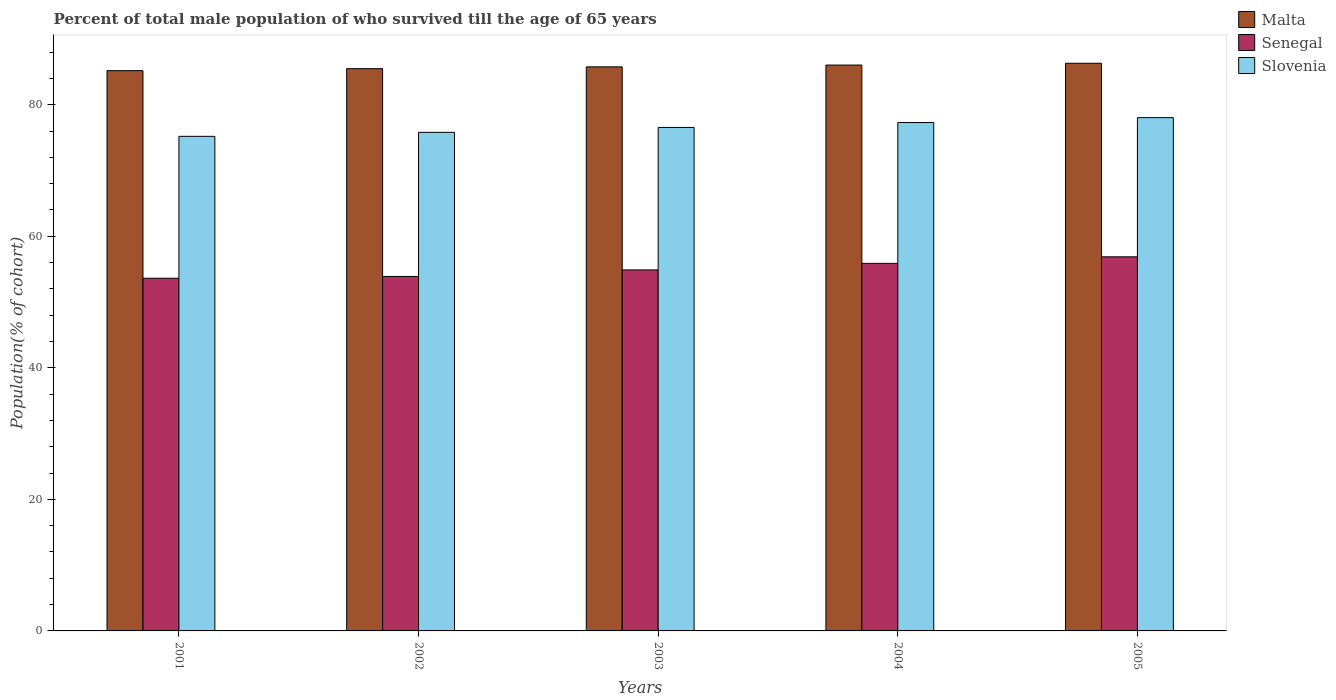How many different coloured bars are there?
Ensure brevity in your answer.  3. Are the number of bars per tick equal to the number of legend labels?
Keep it short and to the point. Yes. Are the number of bars on each tick of the X-axis equal?
Offer a terse response. Yes. How many bars are there on the 5th tick from the left?
Provide a succinct answer. 3. How many bars are there on the 5th tick from the right?
Keep it short and to the point. 3. In how many cases, is the number of bars for a given year not equal to the number of legend labels?
Your response must be concise. 0. What is the percentage of total male population who survived till the age of 65 years in Slovenia in 2005?
Your answer should be very brief. 78.04. Across all years, what is the maximum percentage of total male population who survived till the age of 65 years in Senegal?
Provide a short and direct response. 56.88. Across all years, what is the minimum percentage of total male population who survived till the age of 65 years in Malta?
Ensure brevity in your answer.  85.18. In which year was the percentage of total male population who survived till the age of 65 years in Slovenia minimum?
Your answer should be very brief. 2001. What is the total percentage of total male population who survived till the age of 65 years in Malta in the graph?
Give a very brief answer. 428.75. What is the difference between the percentage of total male population who survived till the age of 65 years in Senegal in 2004 and that in 2005?
Provide a short and direct response. -0.99. What is the difference between the percentage of total male population who survived till the age of 65 years in Senegal in 2005 and the percentage of total male population who survived till the age of 65 years in Slovenia in 2004?
Provide a succinct answer. -20.42. What is the average percentage of total male population who survived till the age of 65 years in Slovenia per year?
Your answer should be compact. 76.57. In the year 2005, what is the difference between the percentage of total male population who survived till the age of 65 years in Malta and percentage of total male population who survived till the age of 65 years in Slovenia?
Offer a very short reply. 8.27. In how many years, is the percentage of total male population who survived till the age of 65 years in Senegal greater than 8 %?
Provide a succinct answer. 5. What is the ratio of the percentage of total male population who survived till the age of 65 years in Malta in 2003 to that in 2005?
Ensure brevity in your answer.  0.99. Is the percentage of total male population who survived till the age of 65 years in Malta in 2002 less than that in 2004?
Make the answer very short. Yes. Is the difference between the percentage of total male population who survived till the age of 65 years in Malta in 2001 and 2002 greater than the difference between the percentage of total male population who survived till the age of 65 years in Slovenia in 2001 and 2002?
Provide a short and direct response. Yes. What is the difference between the highest and the second highest percentage of total male population who survived till the age of 65 years in Slovenia?
Keep it short and to the point. 0.75. What is the difference between the highest and the lowest percentage of total male population who survived till the age of 65 years in Malta?
Give a very brief answer. 1.12. In how many years, is the percentage of total male population who survived till the age of 65 years in Slovenia greater than the average percentage of total male population who survived till the age of 65 years in Slovenia taken over all years?
Ensure brevity in your answer.  2. Is the sum of the percentage of total male population who survived till the age of 65 years in Slovenia in 2001 and 2002 greater than the maximum percentage of total male population who survived till the age of 65 years in Malta across all years?
Provide a succinct answer. Yes. What does the 2nd bar from the left in 2005 represents?
Your answer should be very brief. Senegal. What does the 3rd bar from the right in 2003 represents?
Offer a very short reply. Malta. Is it the case that in every year, the sum of the percentage of total male population who survived till the age of 65 years in Malta and percentage of total male population who survived till the age of 65 years in Slovenia is greater than the percentage of total male population who survived till the age of 65 years in Senegal?
Give a very brief answer. Yes. How many bars are there?
Ensure brevity in your answer.  15. Are the values on the major ticks of Y-axis written in scientific E-notation?
Make the answer very short. No. Does the graph contain grids?
Give a very brief answer. No. How are the legend labels stacked?
Offer a terse response. Vertical. What is the title of the graph?
Your answer should be very brief. Percent of total male population of who survived till the age of 65 years. What is the label or title of the Y-axis?
Offer a terse response. Population(% of cohort). What is the Population(% of cohort) in Malta in 2001?
Your answer should be compact. 85.18. What is the Population(% of cohort) of Senegal in 2001?
Make the answer very short. 53.62. What is the Population(% of cohort) in Slovenia in 2001?
Provide a succinct answer. 75.19. What is the Population(% of cohort) of Malta in 2002?
Your response must be concise. 85.48. What is the Population(% of cohort) in Senegal in 2002?
Your response must be concise. 53.89. What is the Population(% of cohort) in Slovenia in 2002?
Provide a succinct answer. 75.8. What is the Population(% of cohort) of Malta in 2003?
Give a very brief answer. 85.76. What is the Population(% of cohort) in Senegal in 2003?
Provide a short and direct response. 54.89. What is the Population(% of cohort) of Slovenia in 2003?
Provide a succinct answer. 76.55. What is the Population(% of cohort) in Malta in 2004?
Your answer should be very brief. 86.03. What is the Population(% of cohort) of Senegal in 2004?
Your response must be concise. 55.88. What is the Population(% of cohort) of Slovenia in 2004?
Ensure brevity in your answer.  77.29. What is the Population(% of cohort) of Malta in 2005?
Ensure brevity in your answer.  86.3. What is the Population(% of cohort) in Senegal in 2005?
Keep it short and to the point. 56.88. What is the Population(% of cohort) of Slovenia in 2005?
Keep it short and to the point. 78.04. Across all years, what is the maximum Population(% of cohort) in Malta?
Keep it short and to the point. 86.3. Across all years, what is the maximum Population(% of cohort) of Senegal?
Offer a terse response. 56.88. Across all years, what is the maximum Population(% of cohort) of Slovenia?
Offer a very short reply. 78.04. Across all years, what is the minimum Population(% of cohort) of Malta?
Offer a very short reply. 85.18. Across all years, what is the minimum Population(% of cohort) of Senegal?
Provide a short and direct response. 53.62. Across all years, what is the minimum Population(% of cohort) of Slovenia?
Your answer should be compact. 75.19. What is the total Population(% of cohort) of Malta in the graph?
Ensure brevity in your answer.  428.75. What is the total Population(% of cohort) in Senegal in the graph?
Make the answer very short. 275.16. What is the total Population(% of cohort) of Slovenia in the graph?
Your answer should be compact. 382.87. What is the difference between the Population(% of cohort) of Malta in 2001 and that in 2002?
Your answer should be compact. -0.3. What is the difference between the Population(% of cohort) in Senegal in 2001 and that in 2002?
Ensure brevity in your answer.  -0.27. What is the difference between the Population(% of cohort) in Slovenia in 2001 and that in 2002?
Ensure brevity in your answer.  -0.61. What is the difference between the Population(% of cohort) of Malta in 2001 and that in 2003?
Keep it short and to the point. -0.58. What is the difference between the Population(% of cohort) of Senegal in 2001 and that in 2003?
Ensure brevity in your answer.  -1.26. What is the difference between the Population(% of cohort) of Slovenia in 2001 and that in 2003?
Make the answer very short. -1.35. What is the difference between the Population(% of cohort) of Malta in 2001 and that in 2004?
Offer a terse response. -0.85. What is the difference between the Population(% of cohort) of Senegal in 2001 and that in 2004?
Provide a succinct answer. -2.26. What is the difference between the Population(% of cohort) in Slovenia in 2001 and that in 2004?
Keep it short and to the point. -2.1. What is the difference between the Population(% of cohort) of Malta in 2001 and that in 2005?
Your answer should be very brief. -1.12. What is the difference between the Population(% of cohort) of Senegal in 2001 and that in 2005?
Give a very brief answer. -3.25. What is the difference between the Population(% of cohort) of Slovenia in 2001 and that in 2005?
Keep it short and to the point. -2.84. What is the difference between the Population(% of cohort) in Malta in 2002 and that in 2003?
Give a very brief answer. -0.27. What is the difference between the Population(% of cohort) of Senegal in 2002 and that in 2003?
Offer a very short reply. -0.99. What is the difference between the Population(% of cohort) in Slovenia in 2002 and that in 2003?
Your response must be concise. -0.74. What is the difference between the Population(% of cohort) of Malta in 2002 and that in 2004?
Make the answer very short. -0.55. What is the difference between the Population(% of cohort) of Senegal in 2002 and that in 2004?
Your answer should be very brief. -1.99. What is the difference between the Population(% of cohort) of Slovenia in 2002 and that in 2004?
Provide a succinct answer. -1.49. What is the difference between the Population(% of cohort) in Malta in 2002 and that in 2005?
Offer a very short reply. -0.82. What is the difference between the Population(% of cohort) of Senegal in 2002 and that in 2005?
Your answer should be very brief. -2.98. What is the difference between the Population(% of cohort) in Slovenia in 2002 and that in 2005?
Offer a very short reply. -2.24. What is the difference between the Population(% of cohort) of Malta in 2003 and that in 2004?
Your response must be concise. -0.27. What is the difference between the Population(% of cohort) of Senegal in 2003 and that in 2004?
Your answer should be very brief. -0.99. What is the difference between the Population(% of cohort) of Slovenia in 2003 and that in 2004?
Offer a very short reply. -0.74. What is the difference between the Population(% of cohort) in Malta in 2003 and that in 2005?
Your response must be concise. -0.55. What is the difference between the Population(% of cohort) in Senegal in 2003 and that in 2005?
Provide a succinct answer. -1.99. What is the difference between the Population(% of cohort) in Slovenia in 2003 and that in 2005?
Give a very brief answer. -1.49. What is the difference between the Population(% of cohort) of Malta in 2004 and that in 2005?
Your answer should be compact. -0.27. What is the difference between the Population(% of cohort) in Senegal in 2004 and that in 2005?
Make the answer very short. -0.99. What is the difference between the Population(% of cohort) in Slovenia in 2004 and that in 2005?
Provide a succinct answer. -0.74. What is the difference between the Population(% of cohort) in Malta in 2001 and the Population(% of cohort) in Senegal in 2002?
Your answer should be compact. 31.29. What is the difference between the Population(% of cohort) of Malta in 2001 and the Population(% of cohort) of Slovenia in 2002?
Provide a short and direct response. 9.38. What is the difference between the Population(% of cohort) in Senegal in 2001 and the Population(% of cohort) in Slovenia in 2002?
Offer a terse response. -22.18. What is the difference between the Population(% of cohort) of Malta in 2001 and the Population(% of cohort) of Senegal in 2003?
Provide a short and direct response. 30.29. What is the difference between the Population(% of cohort) in Malta in 2001 and the Population(% of cohort) in Slovenia in 2003?
Your response must be concise. 8.63. What is the difference between the Population(% of cohort) of Senegal in 2001 and the Population(% of cohort) of Slovenia in 2003?
Offer a very short reply. -22.92. What is the difference between the Population(% of cohort) of Malta in 2001 and the Population(% of cohort) of Senegal in 2004?
Give a very brief answer. 29.3. What is the difference between the Population(% of cohort) in Malta in 2001 and the Population(% of cohort) in Slovenia in 2004?
Provide a short and direct response. 7.89. What is the difference between the Population(% of cohort) in Senegal in 2001 and the Population(% of cohort) in Slovenia in 2004?
Keep it short and to the point. -23.67. What is the difference between the Population(% of cohort) in Malta in 2001 and the Population(% of cohort) in Senegal in 2005?
Your answer should be compact. 28.3. What is the difference between the Population(% of cohort) in Malta in 2001 and the Population(% of cohort) in Slovenia in 2005?
Give a very brief answer. 7.14. What is the difference between the Population(% of cohort) in Senegal in 2001 and the Population(% of cohort) in Slovenia in 2005?
Provide a succinct answer. -24.41. What is the difference between the Population(% of cohort) in Malta in 2002 and the Population(% of cohort) in Senegal in 2003?
Keep it short and to the point. 30.6. What is the difference between the Population(% of cohort) of Malta in 2002 and the Population(% of cohort) of Slovenia in 2003?
Ensure brevity in your answer.  8.94. What is the difference between the Population(% of cohort) in Senegal in 2002 and the Population(% of cohort) in Slovenia in 2003?
Offer a terse response. -22.65. What is the difference between the Population(% of cohort) in Malta in 2002 and the Population(% of cohort) in Senegal in 2004?
Keep it short and to the point. 29.6. What is the difference between the Population(% of cohort) in Malta in 2002 and the Population(% of cohort) in Slovenia in 2004?
Give a very brief answer. 8.19. What is the difference between the Population(% of cohort) of Senegal in 2002 and the Population(% of cohort) of Slovenia in 2004?
Give a very brief answer. -23.4. What is the difference between the Population(% of cohort) of Malta in 2002 and the Population(% of cohort) of Senegal in 2005?
Ensure brevity in your answer.  28.61. What is the difference between the Population(% of cohort) of Malta in 2002 and the Population(% of cohort) of Slovenia in 2005?
Give a very brief answer. 7.45. What is the difference between the Population(% of cohort) in Senegal in 2002 and the Population(% of cohort) in Slovenia in 2005?
Give a very brief answer. -24.14. What is the difference between the Population(% of cohort) of Malta in 2003 and the Population(% of cohort) of Senegal in 2004?
Offer a very short reply. 29.88. What is the difference between the Population(% of cohort) of Malta in 2003 and the Population(% of cohort) of Slovenia in 2004?
Ensure brevity in your answer.  8.46. What is the difference between the Population(% of cohort) of Senegal in 2003 and the Population(% of cohort) of Slovenia in 2004?
Your response must be concise. -22.4. What is the difference between the Population(% of cohort) in Malta in 2003 and the Population(% of cohort) in Senegal in 2005?
Offer a terse response. 28.88. What is the difference between the Population(% of cohort) in Malta in 2003 and the Population(% of cohort) in Slovenia in 2005?
Keep it short and to the point. 7.72. What is the difference between the Population(% of cohort) in Senegal in 2003 and the Population(% of cohort) in Slovenia in 2005?
Give a very brief answer. -23.15. What is the difference between the Population(% of cohort) of Malta in 2004 and the Population(% of cohort) of Senegal in 2005?
Offer a very short reply. 29.15. What is the difference between the Population(% of cohort) in Malta in 2004 and the Population(% of cohort) in Slovenia in 2005?
Your answer should be very brief. 7.99. What is the difference between the Population(% of cohort) in Senegal in 2004 and the Population(% of cohort) in Slovenia in 2005?
Give a very brief answer. -22.16. What is the average Population(% of cohort) of Malta per year?
Make the answer very short. 85.75. What is the average Population(% of cohort) of Senegal per year?
Provide a succinct answer. 55.03. What is the average Population(% of cohort) of Slovenia per year?
Your response must be concise. 76.57. In the year 2001, what is the difference between the Population(% of cohort) in Malta and Population(% of cohort) in Senegal?
Keep it short and to the point. 31.56. In the year 2001, what is the difference between the Population(% of cohort) in Malta and Population(% of cohort) in Slovenia?
Make the answer very short. 9.98. In the year 2001, what is the difference between the Population(% of cohort) of Senegal and Population(% of cohort) of Slovenia?
Offer a terse response. -21.57. In the year 2002, what is the difference between the Population(% of cohort) of Malta and Population(% of cohort) of Senegal?
Ensure brevity in your answer.  31.59. In the year 2002, what is the difference between the Population(% of cohort) of Malta and Population(% of cohort) of Slovenia?
Your response must be concise. 9.68. In the year 2002, what is the difference between the Population(% of cohort) in Senegal and Population(% of cohort) in Slovenia?
Provide a succinct answer. -21.91. In the year 2003, what is the difference between the Population(% of cohort) in Malta and Population(% of cohort) in Senegal?
Make the answer very short. 30.87. In the year 2003, what is the difference between the Population(% of cohort) of Malta and Population(% of cohort) of Slovenia?
Ensure brevity in your answer.  9.21. In the year 2003, what is the difference between the Population(% of cohort) of Senegal and Population(% of cohort) of Slovenia?
Ensure brevity in your answer.  -21.66. In the year 2004, what is the difference between the Population(% of cohort) of Malta and Population(% of cohort) of Senegal?
Ensure brevity in your answer.  30.15. In the year 2004, what is the difference between the Population(% of cohort) in Malta and Population(% of cohort) in Slovenia?
Your response must be concise. 8.74. In the year 2004, what is the difference between the Population(% of cohort) of Senegal and Population(% of cohort) of Slovenia?
Ensure brevity in your answer.  -21.41. In the year 2005, what is the difference between the Population(% of cohort) of Malta and Population(% of cohort) of Senegal?
Your answer should be compact. 29.43. In the year 2005, what is the difference between the Population(% of cohort) of Malta and Population(% of cohort) of Slovenia?
Make the answer very short. 8.27. In the year 2005, what is the difference between the Population(% of cohort) of Senegal and Population(% of cohort) of Slovenia?
Your answer should be very brief. -21.16. What is the ratio of the Population(% of cohort) of Malta in 2001 to that in 2002?
Offer a terse response. 1. What is the ratio of the Population(% of cohort) in Slovenia in 2001 to that in 2002?
Keep it short and to the point. 0.99. What is the ratio of the Population(% of cohort) in Slovenia in 2001 to that in 2003?
Offer a terse response. 0.98. What is the ratio of the Population(% of cohort) in Malta in 2001 to that in 2004?
Ensure brevity in your answer.  0.99. What is the ratio of the Population(% of cohort) in Senegal in 2001 to that in 2004?
Give a very brief answer. 0.96. What is the ratio of the Population(% of cohort) in Slovenia in 2001 to that in 2004?
Keep it short and to the point. 0.97. What is the ratio of the Population(% of cohort) in Malta in 2001 to that in 2005?
Give a very brief answer. 0.99. What is the ratio of the Population(% of cohort) in Senegal in 2001 to that in 2005?
Offer a very short reply. 0.94. What is the ratio of the Population(% of cohort) of Slovenia in 2001 to that in 2005?
Keep it short and to the point. 0.96. What is the ratio of the Population(% of cohort) of Senegal in 2002 to that in 2003?
Keep it short and to the point. 0.98. What is the ratio of the Population(% of cohort) of Slovenia in 2002 to that in 2003?
Offer a terse response. 0.99. What is the ratio of the Population(% of cohort) of Malta in 2002 to that in 2004?
Provide a short and direct response. 0.99. What is the ratio of the Population(% of cohort) of Senegal in 2002 to that in 2004?
Ensure brevity in your answer.  0.96. What is the ratio of the Population(% of cohort) in Slovenia in 2002 to that in 2004?
Offer a terse response. 0.98. What is the ratio of the Population(% of cohort) of Senegal in 2002 to that in 2005?
Offer a very short reply. 0.95. What is the ratio of the Population(% of cohort) in Slovenia in 2002 to that in 2005?
Offer a very short reply. 0.97. What is the ratio of the Population(% of cohort) of Senegal in 2003 to that in 2004?
Your answer should be very brief. 0.98. What is the ratio of the Population(% of cohort) in Slovenia in 2003 to that in 2004?
Offer a terse response. 0.99. What is the ratio of the Population(% of cohort) in Slovenia in 2003 to that in 2005?
Offer a very short reply. 0.98. What is the ratio of the Population(% of cohort) in Malta in 2004 to that in 2005?
Provide a short and direct response. 1. What is the ratio of the Population(% of cohort) of Senegal in 2004 to that in 2005?
Offer a very short reply. 0.98. What is the difference between the highest and the second highest Population(% of cohort) in Malta?
Your answer should be compact. 0.27. What is the difference between the highest and the second highest Population(% of cohort) in Slovenia?
Offer a terse response. 0.74. What is the difference between the highest and the lowest Population(% of cohort) in Malta?
Make the answer very short. 1.12. What is the difference between the highest and the lowest Population(% of cohort) of Senegal?
Give a very brief answer. 3.25. What is the difference between the highest and the lowest Population(% of cohort) of Slovenia?
Your answer should be very brief. 2.84. 